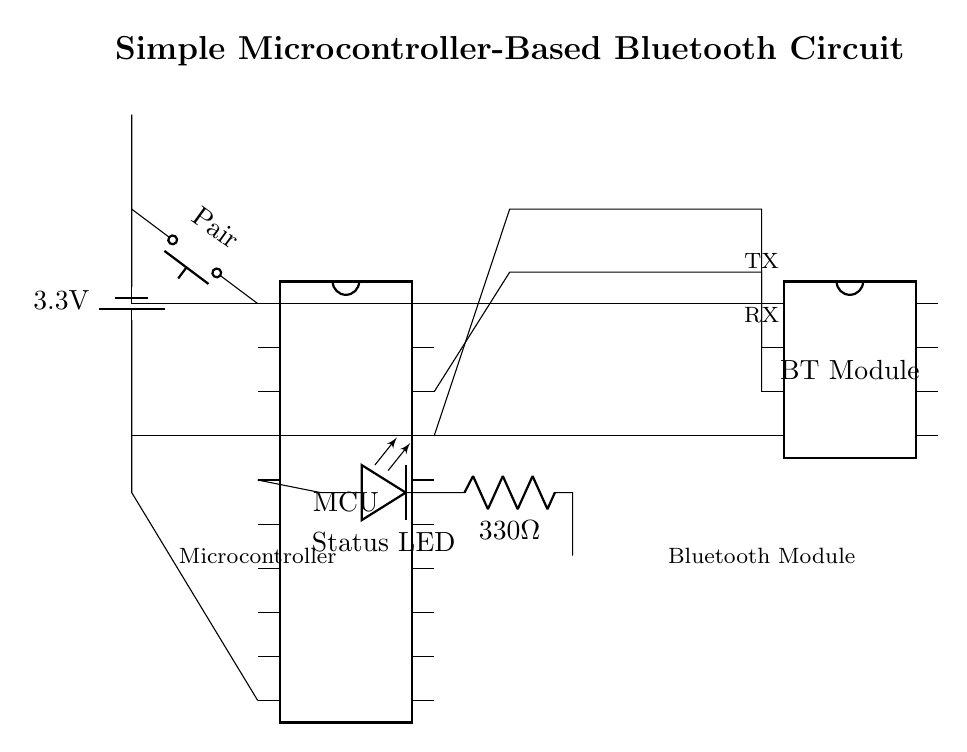What type of microcontroller is used in this circuit? The circuit specifies a microcontroller as "MCU," but does not provide details on its type or model. Thus, it is referred to generically as a microcontroller.
Answer: MCU What is the voltage supplied to the circuit? The circuit shows a battery labeled with "3.3V," indicating this is the operating voltage for all connected components.
Answer: 3.3V How many pins does the Bluetooth module have? The Bluetooth module in the circuit is designated with 8 pins, as indicated in the diagram.
Answer: 8 pins What is the purpose of the pairing button? The pairing button facilitates the Bluetooth pairing process, allowing the user to initiate a connection to other Bluetooth devices. It connects to pin 1 of the microcontroller.
Answer: Initiate pairing What resistor value is used in the circuit? The circuit includes a resistor labeled "330Ω," which is used in series with the status LED for current limiting.
Answer: 330Ω How is the Bluetooth module connected to the microcontroller? The Bluetooth module TX and RX pins are connected to the microcontroller's corresponding TX (pin 17) and RX (pin 18) pins, allowing data transmission.
Answer: TX and RX connections What does the status LED indicate? The status LED lights up to indicate the operational status of the circuit, such as successful pairing or data transmission, based on the microcontroller's output on pin 5.
Answer: Operational status 